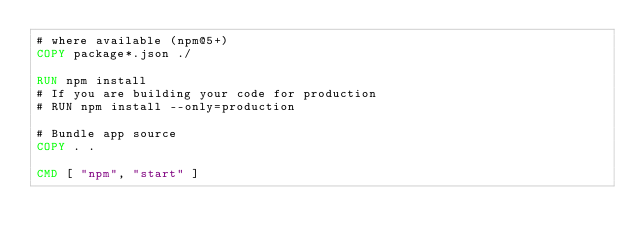Convert code to text. <code><loc_0><loc_0><loc_500><loc_500><_Dockerfile_># where available (npm@5+)
COPY package*.json ./

RUN npm install
# If you are building your code for production
# RUN npm install --only=production

# Bundle app source
COPY . .

CMD [ "npm", "start" ]
</code> 